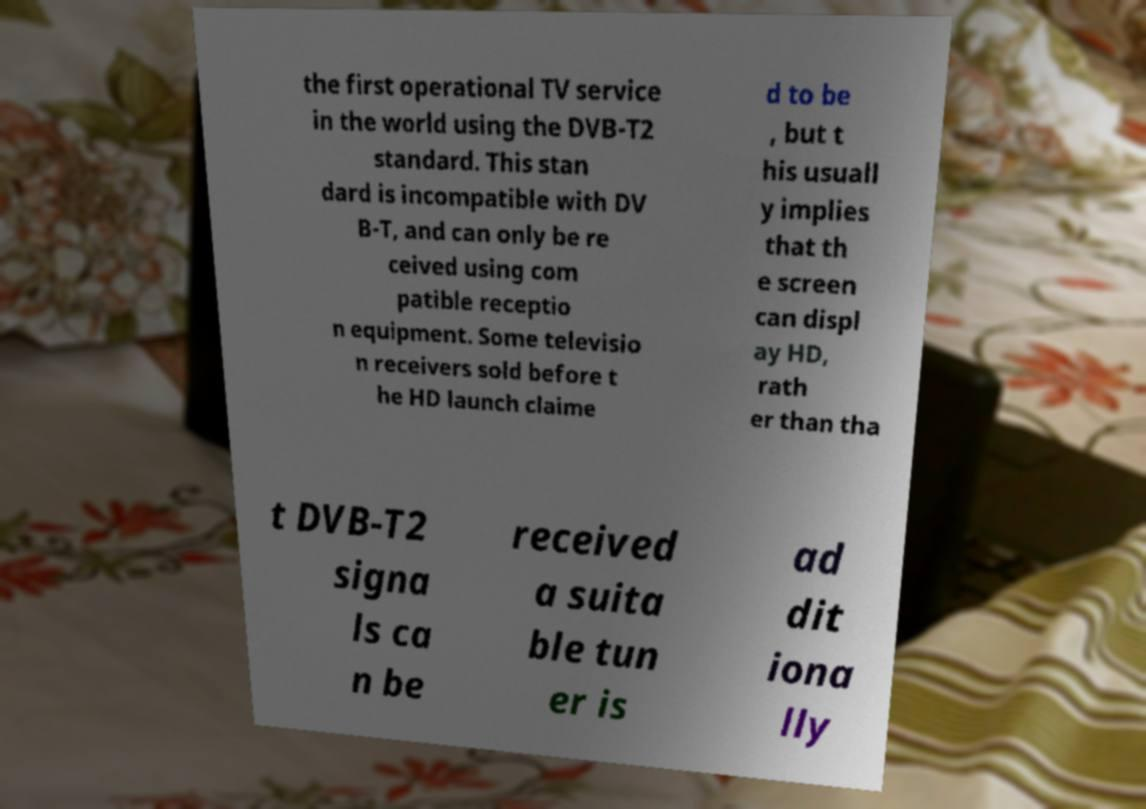Can you accurately transcribe the text from the provided image for me? the first operational TV service in the world using the DVB-T2 standard. This stan dard is incompatible with DV B-T, and can only be re ceived using com patible receptio n equipment. Some televisio n receivers sold before t he HD launch claime d to be , but t his usuall y implies that th e screen can displ ay HD, rath er than tha t DVB-T2 signa ls ca n be received a suita ble tun er is ad dit iona lly 